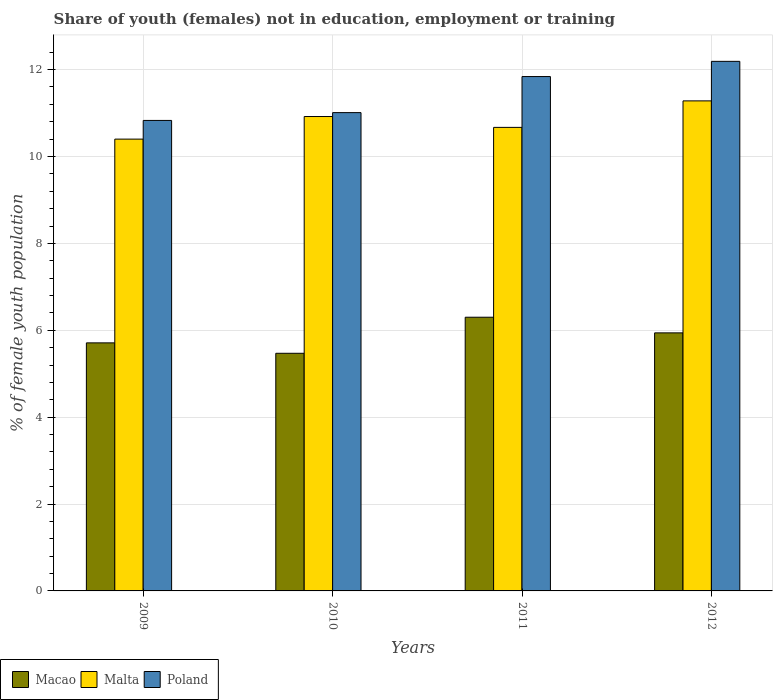How many different coloured bars are there?
Keep it short and to the point. 3. Are the number of bars per tick equal to the number of legend labels?
Provide a short and direct response. Yes. In how many cases, is the number of bars for a given year not equal to the number of legend labels?
Provide a succinct answer. 0. What is the percentage of unemployed female population in in Malta in 2012?
Make the answer very short. 11.28. Across all years, what is the maximum percentage of unemployed female population in in Macao?
Your response must be concise. 6.3. Across all years, what is the minimum percentage of unemployed female population in in Poland?
Offer a very short reply. 10.83. In which year was the percentage of unemployed female population in in Poland maximum?
Your answer should be very brief. 2012. In which year was the percentage of unemployed female population in in Macao minimum?
Your response must be concise. 2010. What is the total percentage of unemployed female population in in Macao in the graph?
Give a very brief answer. 23.42. What is the difference between the percentage of unemployed female population in in Poland in 2011 and that in 2012?
Provide a succinct answer. -0.35. What is the difference between the percentage of unemployed female population in in Poland in 2011 and the percentage of unemployed female population in in Macao in 2009?
Provide a succinct answer. 6.13. What is the average percentage of unemployed female population in in Macao per year?
Provide a succinct answer. 5.86. In the year 2009, what is the difference between the percentage of unemployed female population in in Malta and percentage of unemployed female population in in Poland?
Provide a succinct answer. -0.43. In how many years, is the percentage of unemployed female population in in Poland greater than 6.4 %?
Offer a terse response. 4. What is the ratio of the percentage of unemployed female population in in Poland in 2009 to that in 2012?
Offer a very short reply. 0.89. Is the percentage of unemployed female population in in Macao in 2009 less than that in 2010?
Ensure brevity in your answer.  No. Is the difference between the percentage of unemployed female population in in Malta in 2009 and 2012 greater than the difference between the percentage of unemployed female population in in Poland in 2009 and 2012?
Your answer should be very brief. Yes. What is the difference between the highest and the second highest percentage of unemployed female population in in Macao?
Make the answer very short. 0.36. What is the difference between the highest and the lowest percentage of unemployed female population in in Macao?
Your answer should be compact. 0.83. What does the 3rd bar from the left in 2012 represents?
Your response must be concise. Poland. What does the 1st bar from the right in 2011 represents?
Keep it short and to the point. Poland. How many bars are there?
Make the answer very short. 12. Are all the bars in the graph horizontal?
Provide a short and direct response. No. Does the graph contain grids?
Your answer should be compact. Yes. Where does the legend appear in the graph?
Your answer should be very brief. Bottom left. How many legend labels are there?
Your answer should be compact. 3. What is the title of the graph?
Provide a short and direct response. Share of youth (females) not in education, employment or training. Does "Greece" appear as one of the legend labels in the graph?
Make the answer very short. No. What is the label or title of the Y-axis?
Keep it short and to the point. % of female youth population. What is the % of female youth population of Macao in 2009?
Ensure brevity in your answer.  5.71. What is the % of female youth population in Malta in 2009?
Keep it short and to the point. 10.4. What is the % of female youth population in Poland in 2009?
Your response must be concise. 10.83. What is the % of female youth population of Macao in 2010?
Your response must be concise. 5.47. What is the % of female youth population in Malta in 2010?
Provide a succinct answer. 10.92. What is the % of female youth population of Poland in 2010?
Give a very brief answer. 11.01. What is the % of female youth population of Macao in 2011?
Your answer should be compact. 6.3. What is the % of female youth population of Malta in 2011?
Your answer should be compact. 10.67. What is the % of female youth population of Poland in 2011?
Make the answer very short. 11.84. What is the % of female youth population in Macao in 2012?
Provide a short and direct response. 5.94. What is the % of female youth population of Malta in 2012?
Ensure brevity in your answer.  11.28. What is the % of female youth population of Poland in 2012?
Your answer should be compact. 12.19. Across all years, what is the maximum % of female youth population of Macao?
Offer a very short reply. 6.3. Across all years, what is the maximum % of female youth population in Malta?
Provide a short and direct response. 11.28. Across all years, what is the maximum % of female youth population of Poland?
Make the answer very short. 12.19. Across all years, what is the minimum % of female youth population of Macao?
Keep it short and to the point. 5.47. Across all years, what is the minimum % of female youth population in Malta?
Provide a short and direct response. 10.4. Across all years, what is the minimum % of female youth population in Poland?
Keep it short and to the point. 10.83. What is the total % of female youth population of Macao in the graph?
Keep it short and to the point. 23.42. What is the total % of female youth population in Malta in the graph?
Provide a succinct answer. 43.27. What is the total % of female youth population in Poland in the graph?
Your answer should be compact. 45.87. What is the difference between the % of female youth population of Macao in 2009 and that in 2010?
Ensure brevity in your answer.  0.24. What is the difference between the % of female youth population of Malta in 2009 and that in 2010?
Keep it short and to the point. -0.52. What is the difference between the % of female youth population of Poland in 2009 and that in 2010?
Your answer should be compact. -0.18. What is the difference between the % of female youth population of Macao in 2009 and that in 2011?
Your answer should be compact. -0.59. What is the difference between the % of female youth population of Malta in 2009 and that in 2011?
Offer a very short reply. -0.27. What is the difference between the % of female youth population in Poland in 2009 and that in 2011?
Your response must be concise. -1.01. What is the difference between the % of female youth population of Macao in 2009 and that in 2012?
Offer a very short reply. -0.23. What is the difference between the % of female youth population of Malta in 2009 and that in 2012?
Your response must be concise. -0.88. What is the difference between the % of female youth population in Poland in 2009 and that in 2012?
Offer a very short reply. -1.36. What is the difference between the % of female youth population of Macao in 2010 and that in 2011?
Offer a terse response. -0.83. What is the difference between the % of female youth population of Malta in 2010 and that in 2011?
Make the answer very short. 0.25. What is the difference between the % of female youth population of Poland in 2010 and that in 2011?
Give a very brief answer. -0.83. What is the difference between the % of female youth population in Macao in 2010 and that in 2012?
Ensure brevity in your answer.  -0.47. What is the difference between the % of female youth population of Malta in 2010 and that in 2012?
Your response must be concise. -0.36. What is the difference between the % of female youth population in Poland in 2010 and that in 2012?
Your response must be concise. -1.18. What is the difference between the % of female youth population of Macao in 2011 and that in 2012?
Your answer should be very brief. 0.36. What is the difference between the % of female youth population of Malta in 2011 and that in 2012?
Offer a very short reply. -0.61. What is the difference between the % of female youth population in Poland in 2011 and that in 2012?
Offer a very short reply. -0.35. What is the difference between the % of female youth population of Macao in 2009 and the % of female youth population of Malta in 2010?
Offer a very short reply. -5.21. What is the difference between the % of female youth population in Malta in 2009 and the % of female youth population in Poland in 2010?
Your response must be concise. -0.61. What is the difference between the % of female youth population of Macao in 2009 and the % of female youth population of Malta in 2011?
Provide a succinct answer. -4.96. What is the difference between the % of female youth population of Macao in 2009 and the % of female youth population of Poland in 2011?
Offer a very short reply. -6.13. What is the difference between the % of female youth population of Malta in 2009 and the % of female youth population of Poland in 2011?
Offer a very short reply. -1.44. What is the difference between the % of female youth population in Macao in 2009 and the % of female youth population in Malta in 2012?
Provide a succinct answer. -5.57. What is the difference between the % of female youth population in Macao in 2009 and the % of female youth population in Poland in 2012?
Give a very brief answer. -6.48. What is the difference between the % of female youth population of Malta in 2009 and the % of female youth population of Poland in 2012?
Provide a succinct answer. -1.79. What is the difference between the % of female youth population in Macao in 2010 and the % of female youth population in Malta in 2011?
Keep it short and to the point. -5.2. What is the difference between the % of female youth population in Macao in 2010 and the % of female youth population in Poland in 2011?
Your answer should be compact. -6.37. What is the difference between the % of female youth population of Malta in 2010 and the % of female youth population of Poland in 2011?
Your answer should be very brief. -0.92. What is the difference between the % of female youth population of Macao in 2010 and the % of female youth population of Malta in 2012?
Your answer should be very brief. -5.81. What is the difference between the % of female youth population in Macao in 2010 and the % of female youth population in Poland in 2012?
Ensure brevity in your answer.  -6.72. What is the difference between the % of female youth population in Malta in 2010 and the % of female youth population in Poland in 2012?
Your answer should be very brief. -1.27. What is the difference between the % of female youth population in Macao in 2011 and the % of female youth population in Malta in 2012?
Make the answer very short. -4.98. What is the difference between the % of female youth population of Macao in 2011 and the % of female youth population of Poland in 2012?
Ensure brevity in your answer.  -5.89. What is the difference between the % of female youth population of Malta in 2011 and the % of female youth population of Poland in 2012?
Offer a terse response. -1.52. What is the average % of female youth population in Macao per year?
Ensure brevity in your answer.  5.86. What is the average % of female youth population of Malta per year?
Offer a very short reply. 10.82. What is the average % of female youth population in Poland per year?
Offer a terse response. 11.47. In the year 2009, what is the difference between the % of female youth population of Macao and % of female youth population of Malta?
Offer a very short reply. -4.69. In the year 2009, what is the difference between the % of female youth population of Macao and % of female youth population of Poland?
Make the answer very short. -5.12. In the year 2009, what is the difference between the % of female youth population of Malta and % of female youth population of Poland?
Offer a very short reply. -0.43. In the year 2010, what is the difference between the % of female youth population in Macao and % of female youth population in Malta?
Keep it short and to the point. -5.45. In the year 2010, what is the difference between the % of female youth population in Macao and % of female youth population in Poland?
Give a very brief answer. -5.54. In the year 2010, what is the difference between the % of female youth population in Malta and % of female youth population in Poland?
Make the answer very short. -0.09. In the year 2011, what is the difference between the % of female youth population of Macao and % of female youth population of Malta?
Provide a short and direct response. -4.37. In the year 2011, what is the difference between the % of female youth population in Macao and % of female youth population in Poland?
Provide a succinct answer. -5.54. In the year 2011, what is the difference between the % of female youth population of Malta and % of female youth population of Poland?
Your response must be concise. -1.17. In the year 2012, what is the difference between the % of female youth population in Macao and % of female youth population in Malta?
Your answer should be compact. -5.34. In the year 2012, what is the difference between the % of female youth population of Macao and % of female youth population of Poland?
Provide a short and direct response. -6.25. In the year 2012, what is the difference between the % of female youth population in Malta and % of female youth population in Poland?
Give a very brief answer. -0.91. What is the ratio of the % of female youth population in Macao in 2009 to that in 2010?
Provide a succinct answer. 1.04. What is the ratio of the % of female youth population of Poland in 2009 to that in 2010?
Offer a terse response. 0.98. What is the ratio of the % of female youth population of Macao in 2009 to that in 2011?
Provide a succinct answer. 0.91. What is the ratio of the % of female youth population in Malta in 2009 to that in 2011?
Give a very brief answer. 0.97. What is the ratio of the % of female youth population of Poland in 2009 to that in 2011?
Your answer should be compact. 0.91. What is the ratio of the % of female youth population of Macao in 2009 to that in 2012?
Provide a short and direct response. 0.96. What is the ratio of the % of female youth population in Malta in 2009 to that in 2012?
Give a very brief answer. 0.92. What is the ratio of the % of female youth population in Poland in 2009 to that in 2012?
Make the answer very short. 0.89. What is the ratio of the % of female youth population in Macao in 2010 to that in 2011?
Offer a terse response. 0.87. What is the ratio of the % of female youth population of Malta in 2010 to that in 2011?
Your answer should be very brief. 1.02. What is the ratio of the % of female youth population of Poland in 2010 to that in 2011?
Make the answer very short. 0.93. What is the ratio of the % of female youth population in Macao in 2010 to that in 2012?
Offer a terse response. 0.92. What is the ratio of the % of female youth population in Malta in 2010 to that in 2012?
Your response must be concise. 0.97. What is the ratio of the % of female youth population in Poland in 2010 to that in 2012?
Provide a succinct answer. 0.9. What is the ratio of the % of female youth population of Macao in 2011 to that in 2012?
Your answer should be very brief. 1.06. What is the ratio of the % of female youth population in Malta in 2011 to that in 2012?
Your answer should be very brief. 0.95. What is the ratio of the % of female youth population in Poland in 2011 to that in 2012?
Offer a terse response. 0.97. What is the difference between the highest and the second highest % of female youth population in Macao?
Offer a very short reply. 0.36. What is the difference between the highest and the second highest % of female youth population of Malta?
Your answer should be compact. 0.36. What is the difference between the highest and the lowest % of female youth population of Macao?
Offer a terse response. 0.83. What is the difference between the highest and the lowest % of female youth population in Malta?
Offer a terse response. 0.88. What is the difference between the highest and the lowest % of female youth population of Poland?
Offer a terse response. 1.36. 